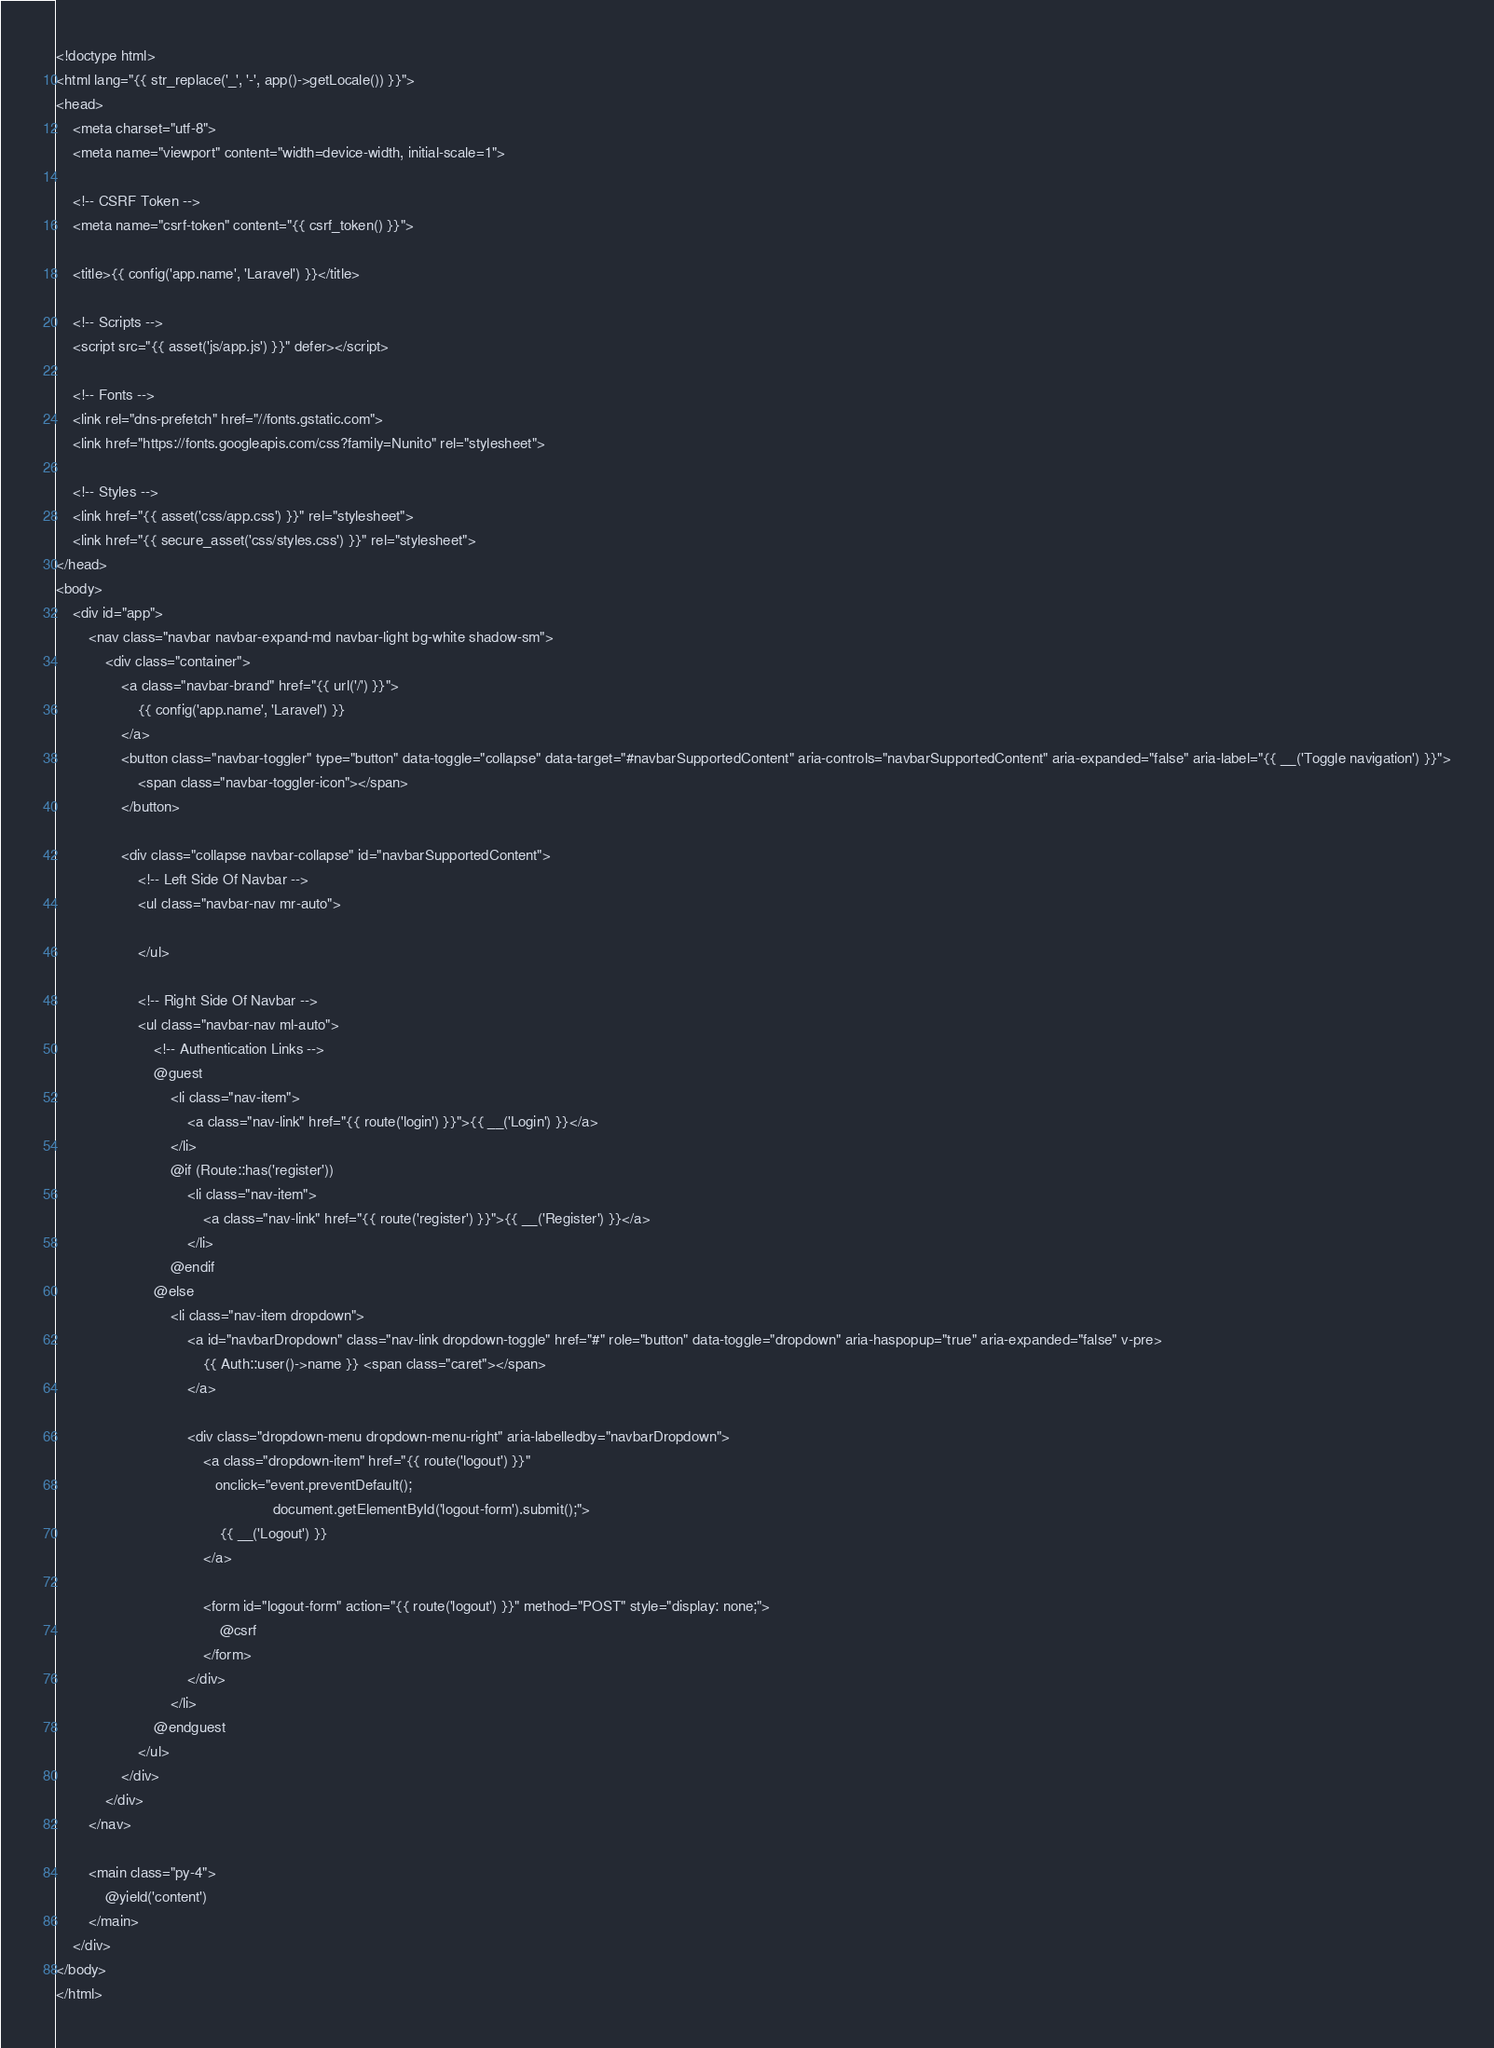<code> <loc_0><loc_0><loc_500><loc_500><_PHP_><!doctype html>
<html lang="{{ str_replace('_', '-', app()->getLocale()) }}">
<head>
    <meta charset="utf-8">
    <meta name="viewport" content="width=device-width, initial-scale=1">

    <!-- CSRF Token -->
    <meta name="csrf-token" content="{{ csrf_token() }}">

    <title>{{ config('app.name', 'Laravel') }}</title>

    <!-- Scripts -->
    <script src="{{ asset('js/app.js') }}" defer></script>

    <!-- Fonts -->
    <link rel="dns-prefetch" href="//fonts.gstatic.com">
    <link href="https://fonts.googleapis.com/css?family=Nunito" rel="stylesheet">

    <!-- Styles -->
    <link href="{{ asset('css/app.css') }}" rel="stylesheet">
    <link href="{{ secure_asset('css/styles.css') }}" rel="stylesheet">
</head>
<body>
    <div id="app">
        <nav class="navbar navbar-expand-md navbar-light bg-white shadow-sm">
            <div class="container">
                <a class="navbar-brand" href="{{ url('/') }}">
                    {{ config('app.name', 'Laravel') }}
                </a>
                <button class="navbar-toggler" type="button" data-toggle="collapse" data-target="#navbarSupportedContent" aria-controls="navbarSupportedContent" aria-expanded="false" aria-label="{{ __('Toggle navigation') }}">
                    <span class="navbar-toggler-icon"></span>
                </button>

                <div class="collapse navbar-collapse" id="navbarSupportedContent">
                    <!-- Left Side Of Navbar -->
                    <ul class="navbar-nav mr-auto">

                    </ul>

                    <!-- Right Side Of Navbar -->
                    <ul class="navbar-nav ml-auto">
                        <!-- Authentication Links -->
                        @guest
                            <li class="nav-item">
                                <a class="nav-link" href="{{ route('login') }}">{{ __('Login') }}</a>
                            </li>
                            @if (Route::has('register'))
                                <li class="nav-item">
                                    <a class="nav-link" href="{{ route('register') }}">{{ __('Register') }}</a>
                                </li>
                            @endif
                        @else
                            <li class="nav-item dropdown">
                                <a id="navbarDropdown" class="nav-link dropdown-toggle" href="#" role="button" data-toggle="dropdown" aria-haspopup="true" aria-expanded="false" v-pre>
                                    {{ Auth::user()->name }} <span class="caret"></span>
                                </a>

                                <div class="dropdown-menu dropdown-menu-right" aria-labelledby="navbarDropdown">
                                    <a class="dropdown-item" href="{{ route('logout') }}"
                                       onclick="event.preventDefault();
                                                     document.getElementById('logout-form').submit();">
                                        {{ __('Logout') }}
                                    </a>

                                    <form id="logout-form" action="{{ route('logout') }}" method="POST" style="display: none;">
                                        @csrf
                                    </form>
                                </div>
                            </li>
                        @endguest
                    </ul>
                </div>
            </div>
        </nav>

        <main class="py-4">
            @yield('content')
        </main>
    </div>
</body>
</html>
</code> 